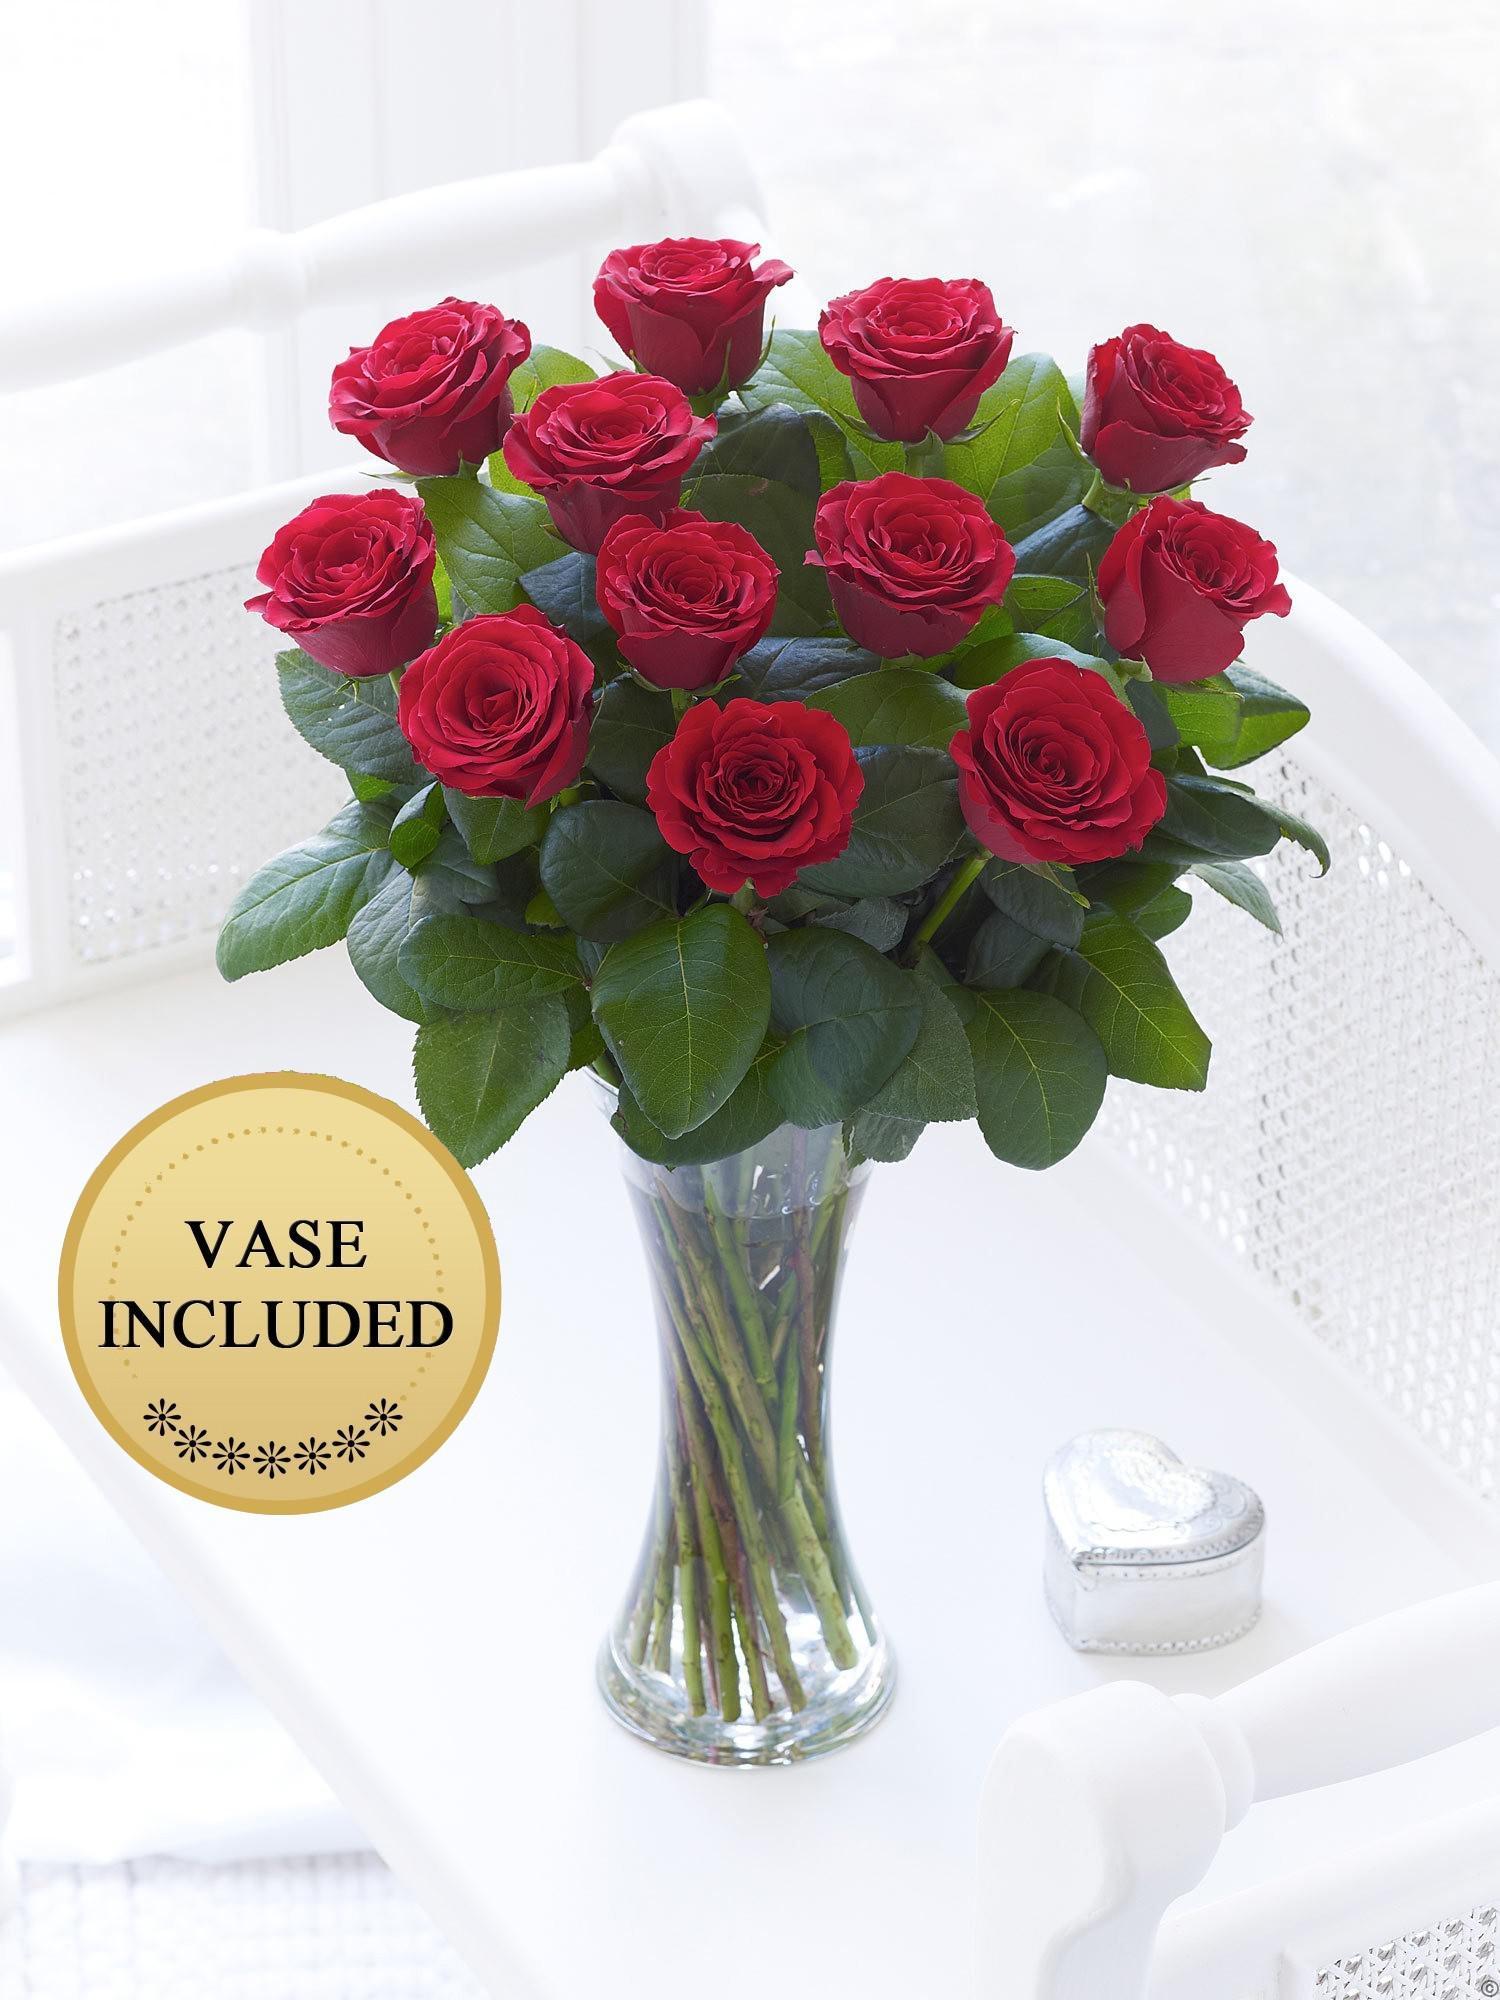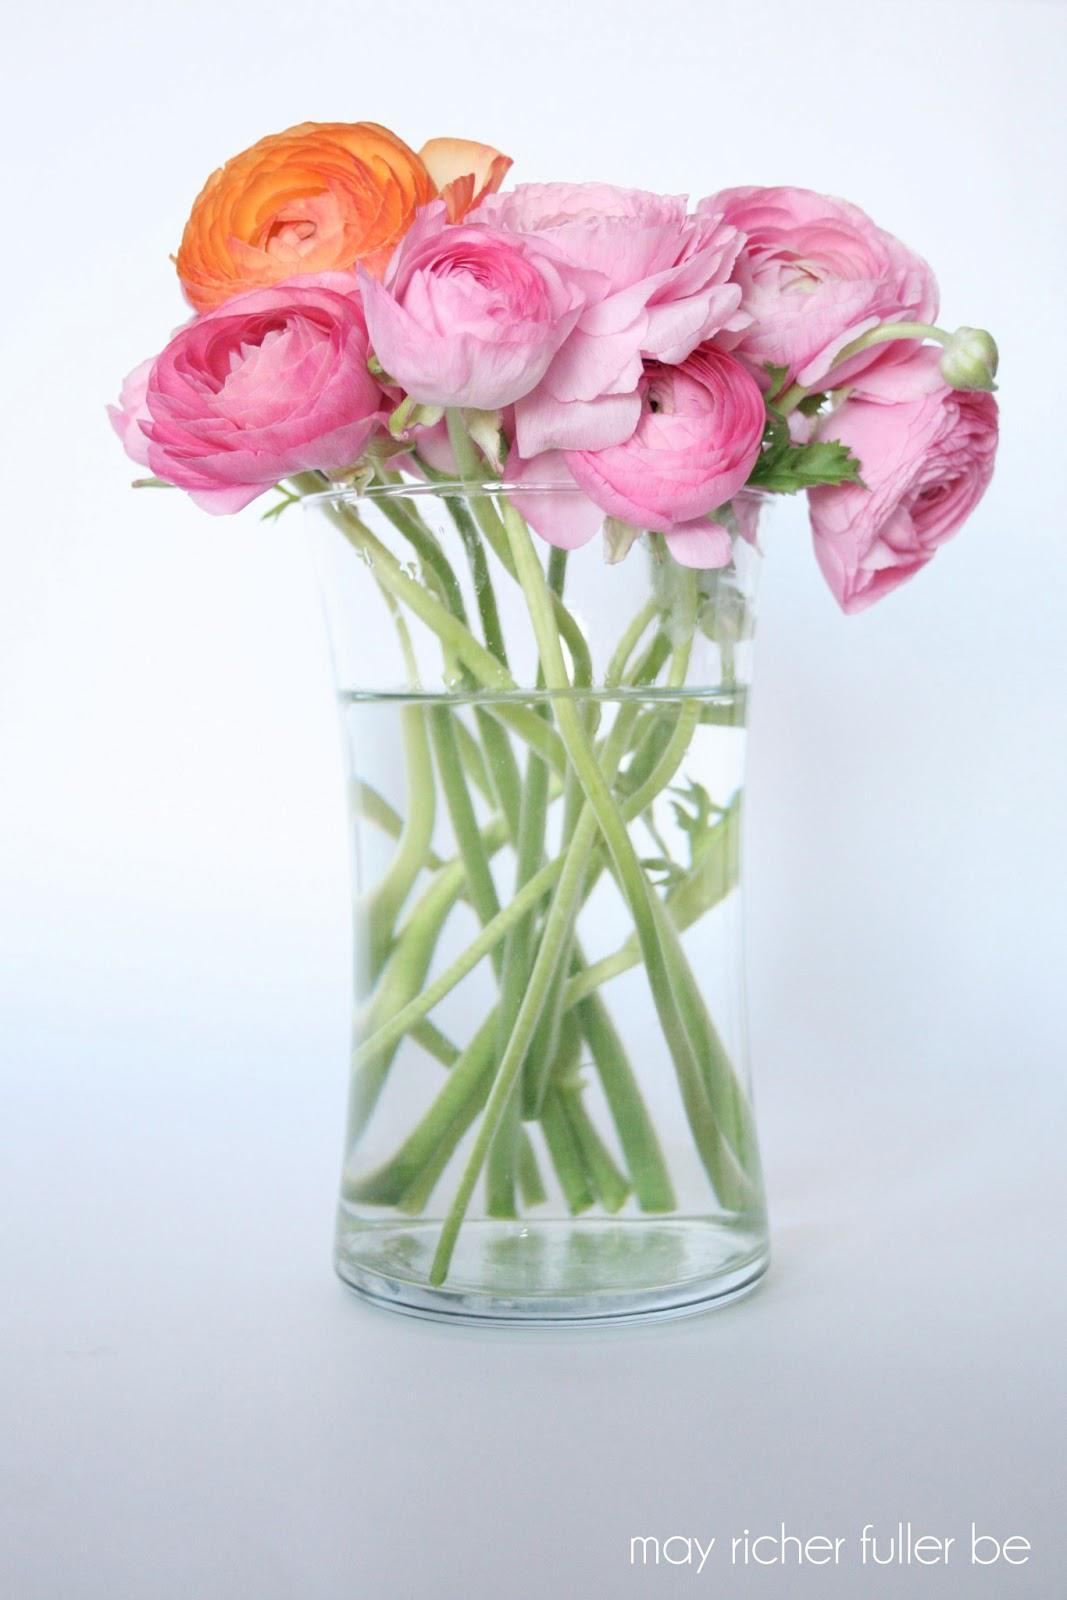The first image is the image on the left, the second image is the image on the right. Assess this claim about the two images: "There are at least five pink flowers with some green leaves set in a square vase to reveal the top of the flowers.". Correct or not? Answer yes or no. No. 